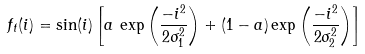Convert formula to latex. <formula><loc_0><loc_0><loc_500><loc_500>f _ { t } ( i ) = \sin ( i ) \left [ a \, \exp \left ( \frac { - i ^ { 2 } } { 2 \sigma _ { 1 } ^ { 2 } } \right ) + ( 1 - a ) \exp \left ( \frac { - i ^ { 2 } } { 2 \sigma _ { 2 } ^ { 2 } } \right ) \right ]</formula> 